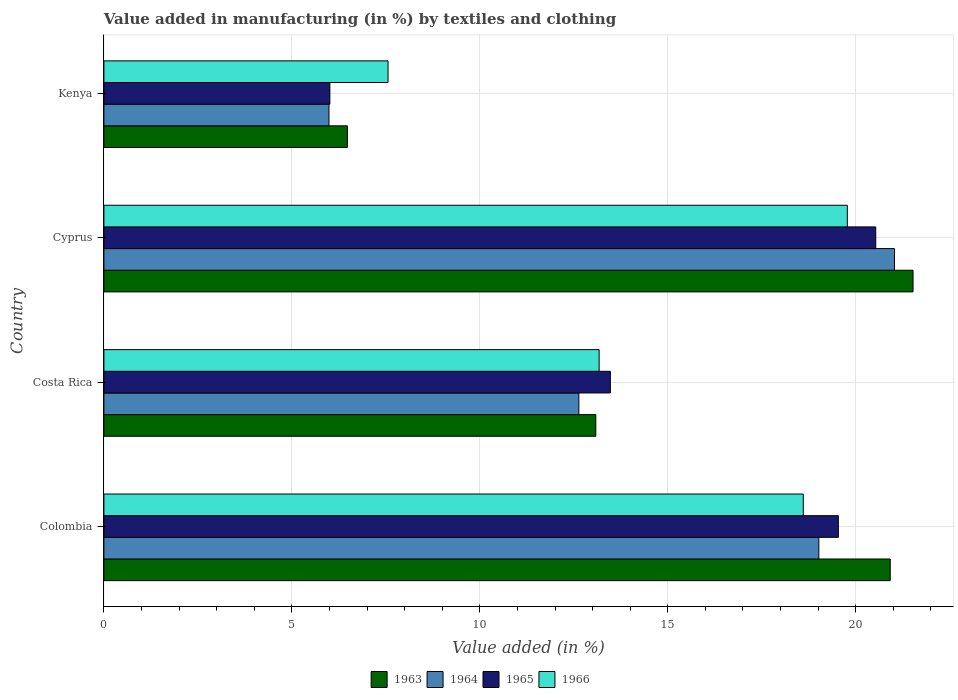How many groups of bars are there?
Give a very brief answer. 4. Are the number of bars per tick equal to the number of legend labels?
Offer a terse response. Yes. Are the number of bars on each tick of the Y-axis equal?
Give a very brief answer. Yes. How many bars are there on the 2nd tick from the top?
Your answer should be very brief. 4. How many bars are there on the 3rd tick from the bottom?
Your response must be concise. 4. What is the label of the 1st group of bars from the top?
Provide a succinct answer. Kenya. What is the percentage of value added in manufacturing by textiles and clothing in 1964 in Costa Rica?
Provide a short and direct response. 12.63. Across all countries, what is the maximum percentage of value added in manufacturing by textiles and clothing in 1964?
Offer a terse response. 21.03. Across all countries, what is the minimum percentage of value added in manufacturing by textiles and clothing in 1966?
Keep it short and to the point. 7.56. In which country was the percentage of value added in manufacturing by textiles and clothing in 1966 maximum?
Keep it short and to the point. Cyprus. In which country was the percentage of value added in manufacturing by textiles and clothing in 1965 minimum?
Give a very brief answer. Kenya. What is the total percentage of value added in manufacturing by textiles and clothing in 1964 in the graph?
Offer a terse response. 58.67. What is the difference between the percentage of value added in manufacturing by textiles and clothing in 1965 in Colombia and that in Cyprus?
Offer a terse response. -0.99. What is the difference between the percentage of value added in manufacturing by textiles and clothing in 1966 in Colombia and the percentage of value added in manufacturing by textiles and clothing in 1964 in Costa Rica?
Offer a very short reply. 5.97. What is the average percentage of value added in manufacturing by textiles and clothing in 1966 per country?
Provide a short and direct response. 14.78. What is the difference between the percentage of value added in manufacturing by textiles and clothing in 1963 and percentage of value added in manufacturing by textiles and clothing in 1965 in Colombia?
Make the answer very short. 1.38. What is the ratio of the percentage of value added in manufacturing by textiles and clothing in 1966 in Colombia to that in Kenya?
Give a very brief answer. 2.46. Is the percentage of value added in manufacturing by textiles and clothing in 1965 in Costa Rica less than that in Cyprus?
Provide a short and direct response. Yes. What is the difference between the highest and the second highest percentage of value added in manufacturing by textiles and clothing in 1964?
Provide a succinct answer. 2.01. What is the difference between the highest and the lowest percentage of value added in manufacturing by textiles and clothing in 1963?
Provide a succinct answer. 15.05. Is it the case that in every country, the sum of the percentage of value added in manufacturing by textiles and clothing in 1966 and percentage of value added in manufacturing by textiles and clothing in 1963 is greater than the sum of percentage of value added in manufacturing by textiles and clothing in 1965 and percentage of value added in manufacturing by textiles and clothing in 1964?
Make the answer very short. No. What does the 1st bar from the top in Kenya represents?
Your response must be concise. 1966. What does the 2nd bar from the bottom in Colombia represents?
Provide a short and direct response. 1964. How many bars are there?
Ensure brevity in your answer.  16. Are all the bars in the graph horizontal?
Offer a terse response. Yes. How many countries are there in the graph?
Your response must be concise. 4. What is the difference between two consecutive major ticks on the X-axis?
Your response must be concise. 5. Are the values on the major ticks of X-axis written in scientific E-notation?
Give a very brief answer. No. Does the graph contain any zero values?
Provide a short and direct response. No. Does the graph contain grids?
Make the answer very short. Yes. What is the title of the graph?
Make the answer very short. Value added in manufacturing (in %) by textiles and clothing. What is the label or title of the X-axis?
Provide a succinct answer. Value added (in %). What is the label or title of the Y-axis?
Your response must be concise. Country. What is the Value added (in %) in 1963 in Colombia?
Offer a terse response. 20.92. What is the Value added (in %) of 1964 in Colombia?
Provide a short and direct response. 19.02. What is the Value added (in %) of 1965 in Colombia?
Your response must be concise. 19.54. What is the Value added (in %) in 1966 in Colombia?
Offer a very short reply. 18.6. What is the Value added (in %) of 1963 in Costa Rica?
Your answer should be very brief. 13.08. What is the Value added (in %) of 1964 in Costa Rica?
Keep it short and to the point. 12.63. What is the Value added (in %) of 1965 in Costa Rica?
Your response must be concise. 13.47. What is the Value added (in %) of 1966 in Costa Rica?
Keep it short and to the point. 13.17. What is the Value added (in %) in 1963 in Cyprus?
Give a very brief answer. 21.52. What is the Value added (in %) of 1964 in Cyprus?
Offer a very short reply. 21.03. What is the Value added (in %) in 1965 in Cyprus?
Offer a very short reply. 20.53. What is the Value added (in %) of 1966 in Cyprus?
Provide a short and direct response. 19.78. What is the Value added (in %) of 1963 in Kenya?
Offer a terse response. 6.48. What is the Value added (in %) of 1964 in Kenya?
Offer a terse response. 5.99. What is the Value added (in %) in 1965 in Kenya?
Your response must be concise. 6.01. What is the Value added (in %) of 1966 in Kenya?
Provide a succinct answer. 7.56. Across all countries, what is the maximum Value added (in %) of 1963?
Offer a very short reply. 21.52. Across all countries, what is the maximum Value added (in %) of 1964?
Give a very brief answer. 21.03. Across all countries, what is the maximum Value added (in %) in 1965?
Keep it short and to the point. 20.53. Across all countries, what is the maximum Value added (in %) in 1966?
Provide a short and direct response. 19.78. Across all countries, what is the minimum Value added (in %) in 1963?
Offer a terse response. 6.48. Across all countries, what is the minimum Value added (in %) of 1964?
Offer a very short reply. 5.99. Across all countries, what is the minimum Value added (in %) in 1965?
Keep it short and to the point. 6.01. Across all countries, what is the minimum Value added (in %) of 1966?
Ensure brevity in your answer.  7.56. What is the total Value added (in %) in 1963 in the graph?
Ensure brevity in your answer.  62. What is the total Value added (in %) of 1964 in the graph?
Your response must be concise. 58.67. What is the total Value added (in %) in 1965 in the graph?
Provide a succinct answer. 59.55. What is the total Value added (in %) of 1966 in the graph?
Offer a terse response. 59.11. What is the difference between the Value added (in %) in 1963 in Colombia and that in Costa Rica?
Provide a short and direct response. 7.83. What is the difference between the Value added (in %) of 1964 in Colombia and that in Costa Rica?
Keep it short and to the point. 6.38. What is the difference between the Value added (in %) of 1965 in Colombia and that in Costa Rica?
Give a very brief answer. 6.06. What is the difference between the Value added (in %) in 1966 in Colombia and that in Costa Rica?
Your answer should be very brief. 5.43. What is the difference between the Value added (in %) in 1963 in Colombia and that in Cyprus?
Your answer should be compact. -0.61. What is the difference between the Value added (in %) in 1964 in Colombia and that in Cyprus?
Keep it short and to the point. -2.01. What is the difference between the Value added (in %) in 1965 in Colombia and that in Cyprus?
Offer a terse response. -0.99. What is the difference between the Value added (in %) of 1966 in Colombia and that in Cyprus?
Give a very brief answer. -1.17. What is the difference between the Value added (in %) in 1963 in Colombia and that in Kenya?
Keep it short and to the point. 14.44. What is the difference between the Value added (in %) in 1964 in Colombia and that in Kenya?
Your answer should be compact. 13.03. What is the difference between the Value added (in %) of 1965 in Colombia and that in Kenya?
Your answer should be compact. 13.53. What is the difference between the Value added (in %) of 1966 in Colombia and that in Kenya?
Your answer should be very brief. 11.05. What is the difference between the Value added (in %) in 1963 in Costa Rica and that in Cyprus?
Offer a terse response. -8.44. What is the difference between the Value added (in %) in 1964 in Costa Rica and that in Cyprus?
Give a very brief answer. -8.4. What is the difference between the Value added (in %) of 1965 in Costa Rica and that in Cyprus?
Give a very brief answer. -7.06. What is the difference between the Value added (in %) in 1966 in Costa Rica and that in Cyprus?
Your answer should be very brief. -6.6. What is the difference between the Value added (in %) of 1963 in Costa Rica and that in Kenya?
Keep it short and to the point. 6.61. What is the difference between the Value added (in %) in 1964 in Costa Rica and that in Kenya?
Your answer should be very brief. 6.65. What is the difference between the Value added (in %) of 1965 in Costa Rica and that in Kenya?
Your answer should be compact. 7.46. What is the difference between the Value added (in %) of 1966 in Costa Rica and that in Kenya?
Provide a succinct answer. 5.62. What is the difference between the Value added (in %) of 1963 in Cyprus and that in Kenya?
Provide a short and direct response. 15.05. What is the difference between the Value added (in %) of 1964 in Cyprus and that in Kenya?
Provide a short and direct response. 15.04. What is the difference between the Value added (in %) in 1965 in Cyprus and that in Kenya?
Keep it short and to the point. 14.52. What is the difference between the Value added (in %) in 1966 in Cyprus and that in Kenya?
Provide a short and direct response. 12.22. What is the difference between the Value added (in %) in 1963 in Colombia and the Value added (in %) in 1964 in Costa Rica?
Keep it short and to the point. 8.28. What is the difference between the Value added (in %) of 1963 in Colombia and the Value added (in %) of 1965 in Costa Rica?
Give a very brief answer. 7.44. What is the difference between the Value added (in %) in 1963 in Colombia and the Value added (in %) in 1966 in Costa Rica?
Make the answer very short. 7.74. What is the difference between the Value added (in %) in 1964 in Colombia and the Value added (in %) in 1965 in Costa Rica?
Keep it short and to the point. 5.55. What is the difference between the Value added (in %) of 1964 in Colombia and the Value added (in %) of 1966 in Costa Rica?
Your answer should be compact. 5.84. What is the difference between the Value added (in %) in 1965 in Colombia and the Value added (in %) in 1966 in Costa Rica?
Offer a terse response. 6.36. What is the difference between the Value added (in %) in 1963 in Colombia and the Value added (in %) in 1964 in Cyprus?
Provide a succinct answer. -0.11. What is the difference between the Value added (in %) in 1963 in Colombia and the Value added (in %) in 1965 in Cyprus?
Provide a short and direct response. 0.39. What is the difference between the Value added (in %) in 1963 in Colombia and the Value added (in %) in 1966 in Cyprus?
Your answer should be compact. 1.14. What is the difference between the Value added (in %) in 1964 in Colombia and the Value added (in %) in 1965 in Cyprus?
Provide a short and direct response. -1.51. What is the difference between the Value added (in %) in 1964 in Colombia and the Value added (in %) in 1966 in Cyprus?
Your response must be concise. -0.76. What is the difference between the Value added (in %) of 1965 in Colombia and the Value added (in %) of 1966 in Cyprus?
Provide a succinct answer. -0.24. What is the difference between the Value added (in %) in 1963 in Colombia and the Value added (in %) in 1964 in Kenya?
Your answer should be compact. 14.93. What is the difference between the Value added (in %) of 1963 in Colombia and the Value added (in %) of 1965 in Kenya?
Provide a short and direct response. 14.91. What is the difference between the Value added (in %) of 1963 in Colombia and the Value added (in %) of 1966 in Kenya?
Your response must be concise. 13.36. What is the difference between the Value added (in %) in 1964 in Colombia and the Value added (in %) in 1965 in Kenya?
Your answer should be very brief. 13.01. What is the difference between the Value added (in %) in 1964 in Colombia and the Value added (in %) in 1966 in Kenya?
Your answer should be very brief. 11.46. What is the difference between the Value added (in %) of 1965 in Colombia and the Value added (in %) of 1966 in Kenya?
Offer a very short reply. 11.98. What is the difference between the Value added (in %) of 1963 in Costa Rica and the Value added (in %) of 1964 in Cyprus?
Offer a terse response. -7.95. What is the difference between the Value added (in %) in 1963 in Costa Rica and the Value added (in %) in 1965 in Cyprus?
Offer a terse response. -7.45. What is the difference between the Value added (in %) of 1963 in Costa Rica and the Value added (in %) of 1966 in Cyprus?
Ensure brevity in your answer.  -6.69. What is the difference between the Value added (in %) in 1964 in Costa Rica and the Value added (in %) in 1965 in Cyprus?
Ensure brevity in your answer.  -7.9. What is the difference between the Value added (in %) in 1964 in Costa Rica and the Value added (in %) in 1966 in Cyprus?
Offer a terse response. -7.14. What is the difference between the Value added (in %) in 1965 in Costa Rica and the Value added (in %) in 1966 in Cyprus?
Your answer should be compact. -6.3. What is the difference between the Value added (in %) of 1963 in Costa Rica and the Value added (in %) of 1964 in Kenya?
Make the answer very short. 7.1. What is the difference between the Value added (in %) of 1963 in Costa Rica and the Value added (in %) of 1965 in Kenya?
Give a very brief answer. 7.07. What is the difference between the Value added (in %) in 1963 in Costa Rica and the Value added (in %) in 1966 in Kenya?
Offer a very short reply. 5.53. What is the difference between the Value added (in %) in 1964 in Costa Rica and the Value added (in %) in 1965 in Kenya?
Provide a short and direct response. 6.62. What is the difference between the Value added (in %) in 1964 in Costa Rica and the Value added (in %) in 1966 in Kenya?
Your answer should be compact. 5.08. What is the difference between the Value added (in %) of 1965 in Costa Rica and the Value added (in %) of 1966 in Kenya?
Your answer should be very brief. 5.91. What is the difference between the Value added (in %) of 1963 in Cyprus and the Value added (in %) of 1964 in Kenya?
Offer a terse response. 15.54. What is the difference between the Value added (in %) in 1963 in Cyprus and the Value added (in %) in 1965 in Kenya?
Provide a short and direct response. 15.51. What is the difference between the Value added (in %) of 1963 in Cyprus and the Value added (in %) of 1966 in Kenya?
Ensure brevity in your answer.  13.97. What is the difference between the Value added (in %) of 1964 in Cyprus and the Value added (in %) of 1965 in Kenya?
Keep it short and to the point. 15.02. What is the difference between the Value added (in %) of 1964 in Cyprus and the Value added (in %) of 1966 in Kenya?
Give a very brief answer. 13.47. What is the difference between the Value added (in %) in 1965 in Cyprus and the Value added (in %) in 1966 in Kenya?
Keep it short and to the point. 12.97. What is the average Value added (in %) in 1963 per country?
Keep it short and to the point. 15.5. What is the average Value added (in %) in 1964 per country?
Your response must be concise. 14.67. What is the average Value added (in %) of 1965 per country?
Make the answer very short. 14.89. What is the average Value added (in %) in 1966 per country?
Your answer should be very brief. 14.78. What is the difference between the Value added (in %) in 1963 and Value added (in %) in 1964 in Colombia?
Offer a very short reply. 1.9. What is the difference between the Value added (in %) of 1963 and Value added (in %) of 1965 in Colombia?
Ensure brevity in your answer.  1.38. What is the difference between the Value added (in %) in 1963 and Value added (in %) in 1966 in Colombia?
Offer a terse response. 2.31. What is the difference between the Value added (in %) in 1964 and Value added (in %) in 1965 in Colombia?
Your response must be concise. -0.52. What is the difference between the Value added (in %) in 1964 and Value added (in %) in 1966 in Colombia?
Your answer should be very brief. 0.41. What is the difference between the Value added (in %) in 1965 and Value added (in %) in 1966 in Colombia?
Your answer should be compact. 0.93. What is the difference between the Value added (in %) of 1963 and Value added (in %) of 1964 in Costa Rica?
Offer a terse response. 0.45. What is the difference between the Value added (in %) of 1963 and Value added (in %) of 1965 in Costa Rica?
Provide a short and direct response. -0.39. What is the difference between the Value added (in %) in 1963 and Value added (in %) in 1966 in Costa Rica?
Your answer should be very brief. -0.09. What is the difference between the Value added (in %) in 1964 and Value added (in %) in 1965 in Costa Rica?
Provide a short and direct response. -0.84. What is the difference between the Value added (in %) in 1964 and Value added (in %) in 1966 in Costa Rica?
Your response must be concise. -0.54. What is the difference between the Value added (in %) of 1965 and Value added (in %) of 1966 in Costa Rica?
Your response must be concise. 0.3. What is the difference between the Value added (in %) in 1963 and Value added (in %) in 1964 in Cyprus?
Your response must be concise. 0.49. What is the difference between the Value added (in %) of 1963 and Value added (in %) of 1966 in Cyprus?
Offer a terse response. 1.75. What is the difference between the Value added (in %) of 1964 and Value added (in %) of 1965 in Cyprus?
Keep it short and to the point. 0.5. What is the difference between the Value added (in %) in 1964 and Value added (in %) in 1966 in Cyprus?
Your answer should be very brief. 1.25. What is the difference between the Value added (in %) of 1965 and Value added (in %) of 1966 in Cyprus?
Provide a short and direct response. 0.76. What is the difference between the Value added (in %) in 1963 and Value added (in %) in 1964 in Kenya?
Keep it short and to the point. 0.49. What is the difference between the Value added (in %) of 1963 and Value added (in %) of 1965 in Kenya?
Offer a terse response. 0.47. What is the difference between the Value added (in %) in 1963 and Value added (in %) in 1966 in Kenya?
Give a very brief answer. -1.08. What is the difference between the Value added (in %) in 1964 and Value added (in %) in 1965 in Kenya?
Your response must be concise. -0.02. What is the difference between the Value added (in %) in 1964 and Value added (in %) in 1966 in Kenya?
Give a very brief answer. -1.57. What is the difference between the Value added (in %) in 1965 and Value added (in %) in 1966 in Kenya?
Make the answer very short. -1.55. What is the ratio of the Value added (in %) of 1963 in Colombia to that in Costa Rica?
Offer a terse response. 1.6. What is the ratio of the Value added (in %) of 1964 in Colombia to that in Costa Rica?
Give a very brief answer. 1.51. What is the ratio of the Value added (in %) of 1965 in Colombia to that in Costa Rica?
Your response must be concise. 1.45. What is the ratio of the Value added (in %) in 1966 in Colombia to that in Costa Rica?
Make the answer very short. 1.41. What is the ratio of the Value added (in %) of 1963 in Colombia to that in Cyprus?
Provide a short and direct response. 0.97. What is the ratio of the Value added (in %) of 1964 in Colombia to that in Cyprus?
Provide a short and direct response. 0.9. What is the ratio of the Value added (in %) of 1965 in Colombia to that in Cyprus?
Ensure brevity in your answer.  0.95. What is the ratio of the Value added (in %) of 1966 in Colombia to that in Cyprus?
Your answer should be compact. 0.94. What is the ratio of the Value added (in %) in 1963 in Colombia to that in Kenya?
Your response must be concise. 3.23. What is the ratio of the Value added (in %) in 1964 in Colombia to that in Kenya?
Your response must be concise. 3.18. What is the ratio of the Value added (in %) of 1966 in Colombia to that in Kenya?
Provide a short and direct response. 2.46. What is the ratio of the Value added (in %) of 1963 in Costa Rica to that in Cyprus?
Provide a short and direct response. 0.61. What is the ratio of the Value added (in %) of 1964 in Costa Rica to that in Cyprus?
Provide a short and direct response. 0.6. What is the ratio of the Value added (in %) of 1965 in Costa Rica to that in Cyprus?
Ensure brevity in your answer.  0.66. What is the ratio of the Value added (in %) in 1966 in Costa Rica to that in Cyprus?
Make the answer very short. 0.67. What is the ratio of the Value added (in %) in 1963 in Costa Rica to that in Kenya?
Give a very brief answer. 2.02. What is the ratio of the Value added (in %) of 1964 in Costa Rica to that in Kenya?
Ensure brevity in your answer.  2.11. What is the ratio of the Value added (in %) of 1965 in Costa Rica to that in Kenya?
Ensure brevity in your answer.  2.24. What is the ratio of the Value added (in %) in 1966 in Costa Rica to that in Kenya?
Ensure brevity in your answer.  1.74. What is the ratio of the Value added (in %) of 1963 in Cyprus to that in Kenya?
Make the answer very short. 3.32. What is the ratio of the Value added (in %) in 1964 in Cyprus to that in Kenya?
Make the answer very short. 3.51. What is the ratio of the Value added (in %) in 1965 in Cyprus to that in Kenya?
Provide a short and direct response. 3.42. What is the ratio of the Value added (in %) of 1966 in Cyprus to that in Kenya?
Make the answer very short. 2.62. What is the difference between the highest and the second highest Value added (in %) in 1963?
Offer a terse response. 0.61. What is the difference between the highest and the second highest Value added (in %) of 1964?
Make the answer very short. 2.01. What is the difference between the highest and the second highest Value added (in %) of 1965?
Your answer should be very brief. 0.99. What is the difference between the highest and the second highest Value added (in %) of 1966?
Give a very brief answer. 1.17. What is the difference between the highest and the lowest Value added (in %) of 1963?
Give a very brief answer. 15.05. What is the difference between the highest and the lowest Value added (in %) of 1964?
Provide a succinct answer. 15.04. What is the difference between the highest and the lowest Value added (in %) in 1965?
Your response must be concise. 14.52. What is the difference between the highest and the lowest Value added (in %) of 1966?
Provide a short and direct response. 12.22. 